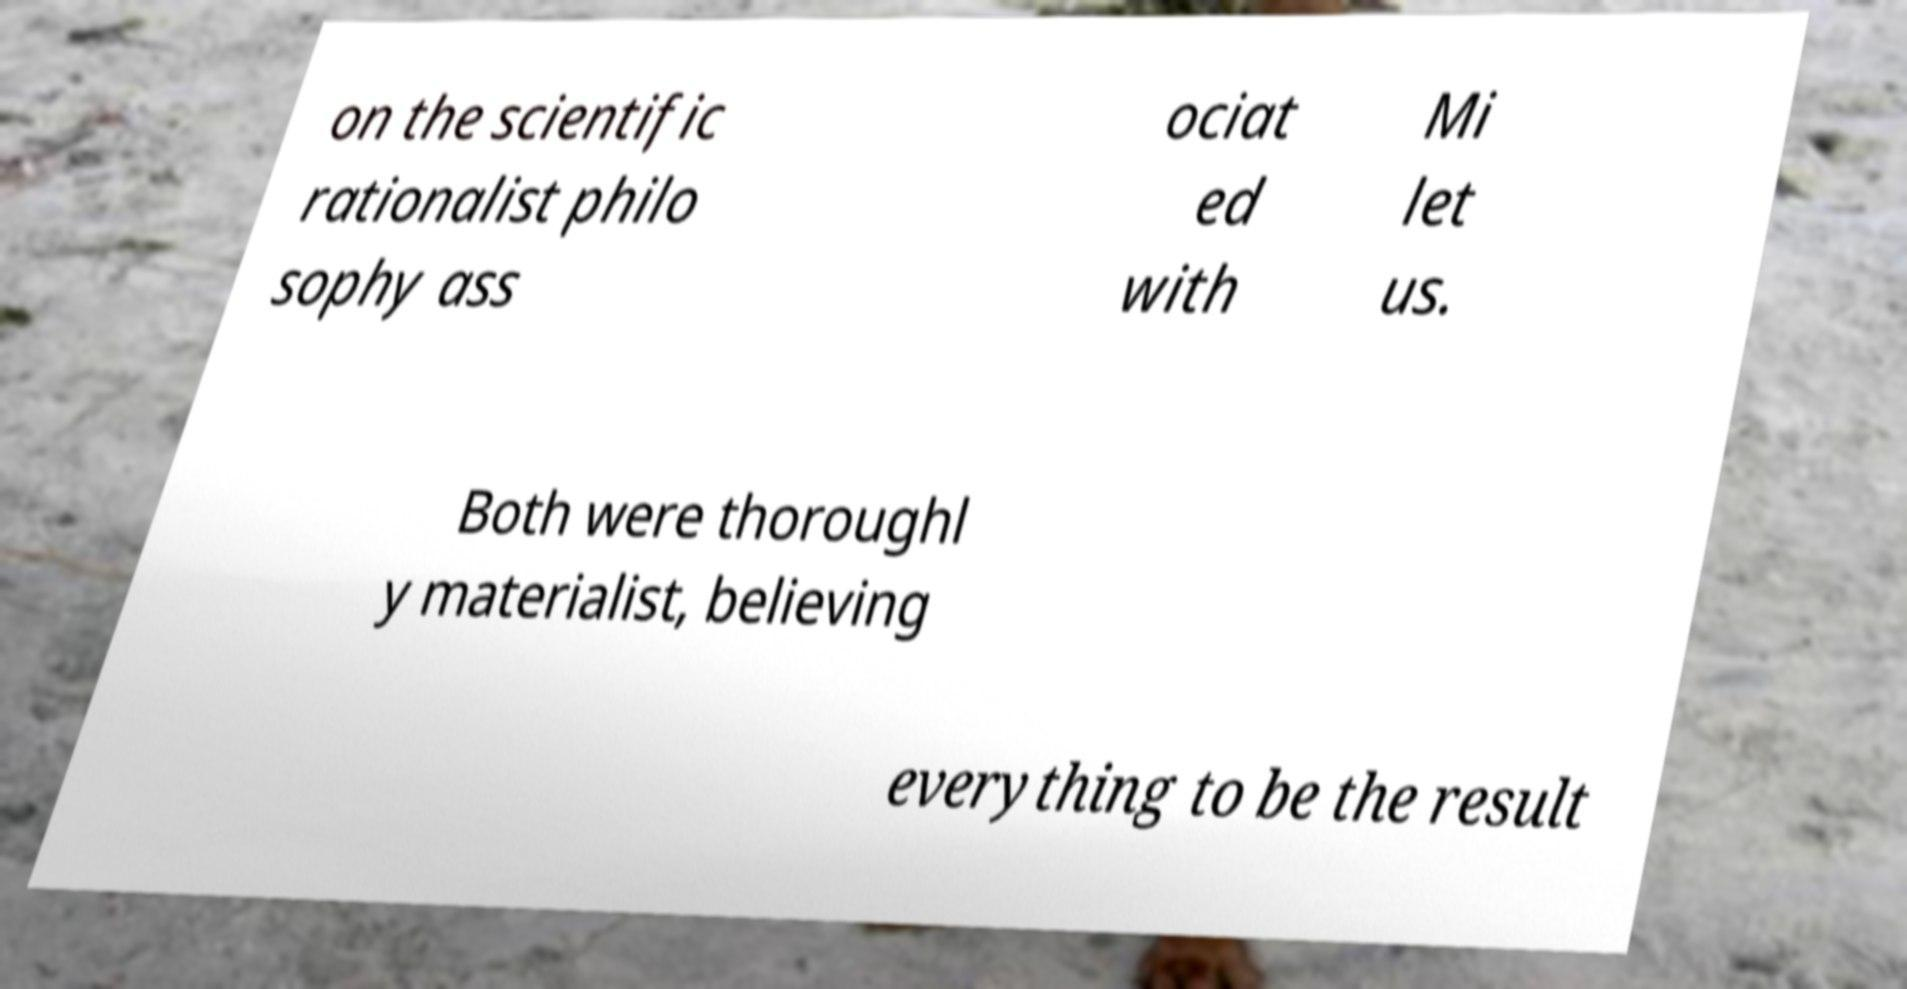Can you accurately transcribe the text from the provided image for me? on the scientific rationalist philo sophy ass ociat ed with Mi let us. Both were thoroughl y materialist, believing everything to be the result 